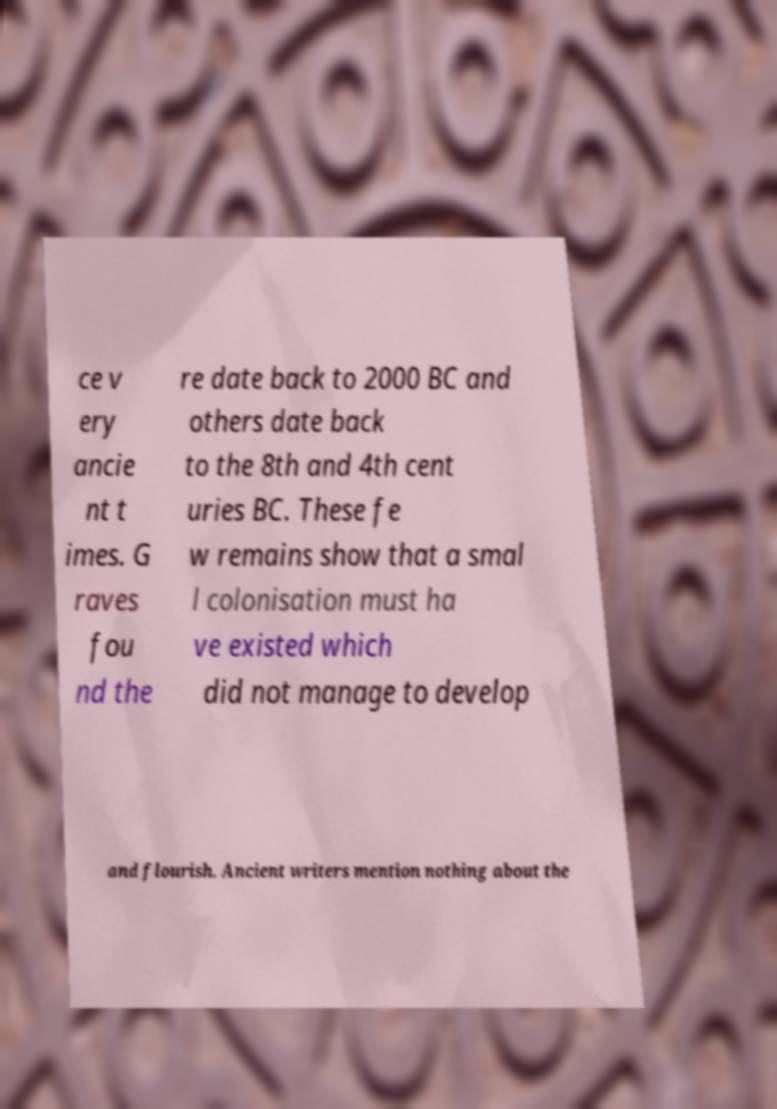I need the written content from this picture converted into text. Can you do that? ce v ery ancie nt t imes. G raves fou nd the re date back to 2000 BC and others date back to the 8th and 4th cent uries BC. These fe w remains show that a smal l colonisation must ha ve existed which did not manage to develop and flourish. Ancient writers mention nothing about the 